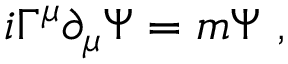<formula> <loc_0><loc_0><loc_500><loc_500>i \Gamma ^ { \mu } \partial _ { \mu } \Psi = m \Psi ,</formula> 